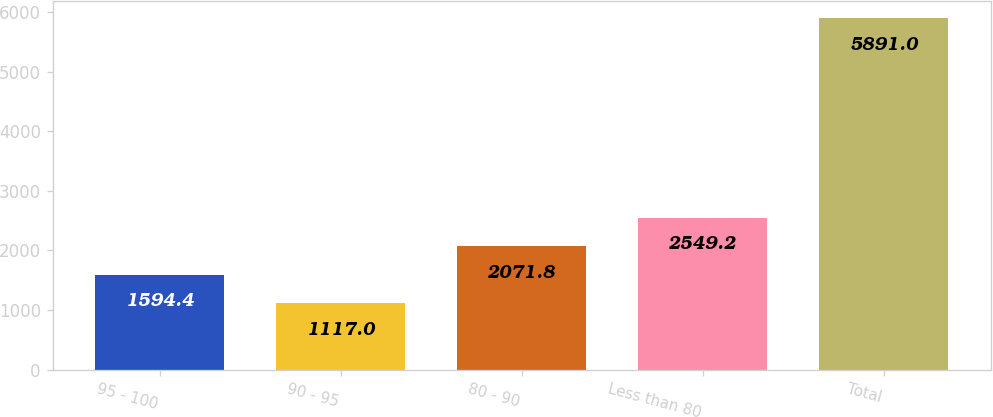<chart> <loc_0><loc_0><loc_500><loc_500><bar_chart><fcel>95 - 100<fcel>90 - 95<fcel>80 - 90<fcel>Less than 80<fcel>Total<nl><fcel>1594.4<fcel>1117<fcel>2071.8<fcel>2549.2<fcel>5891<nl></chart> 